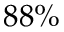Convert formula to latex. <formula><loc_0><loc_0><loc_500><loc_500>8 8 \%</formula> 